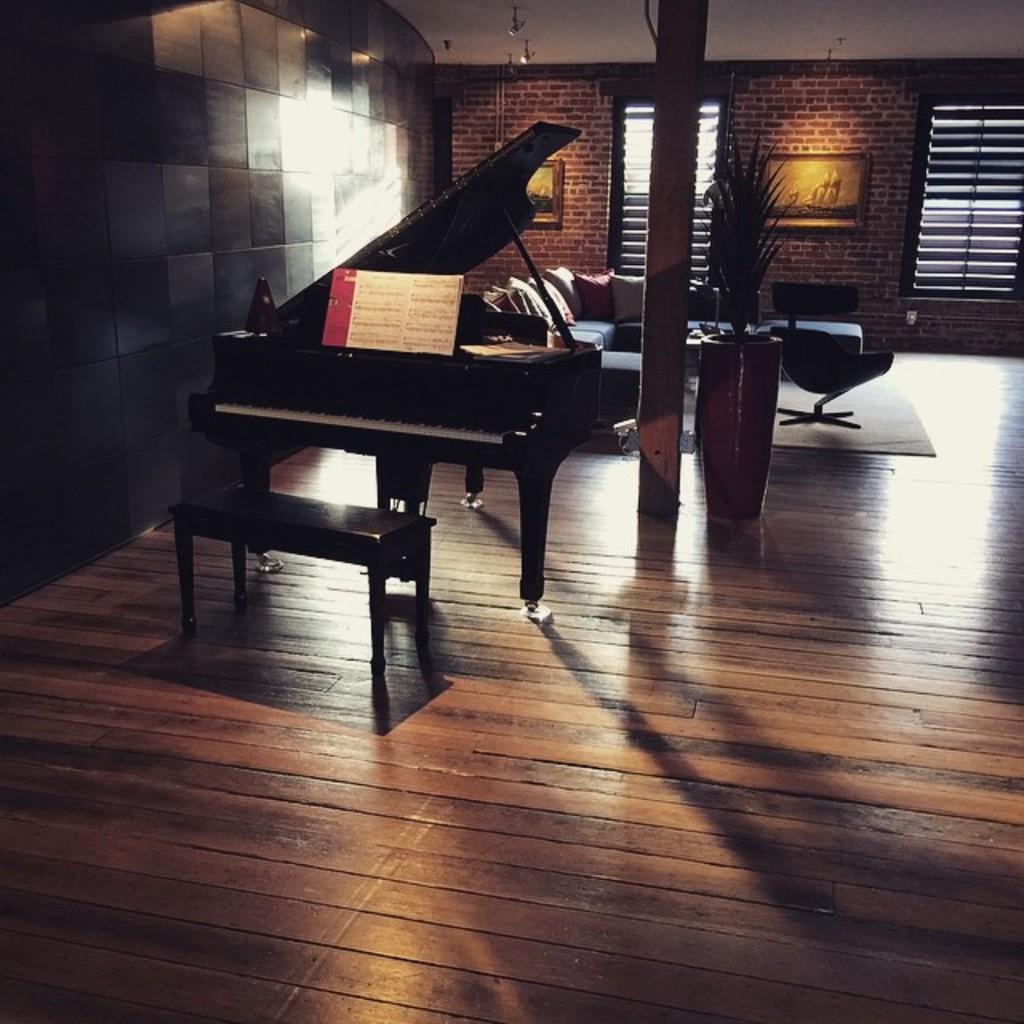Please provide a concise description of this image. In the middle left, piano is there. In front of that a bench is there. A roof top is white in color. The background wall is of bricks on which wall painting is there. In the middle there is a pillar of brown in color. left side wall is of brown in color. In the middle, a window is visible. The image is taken inside a house. 